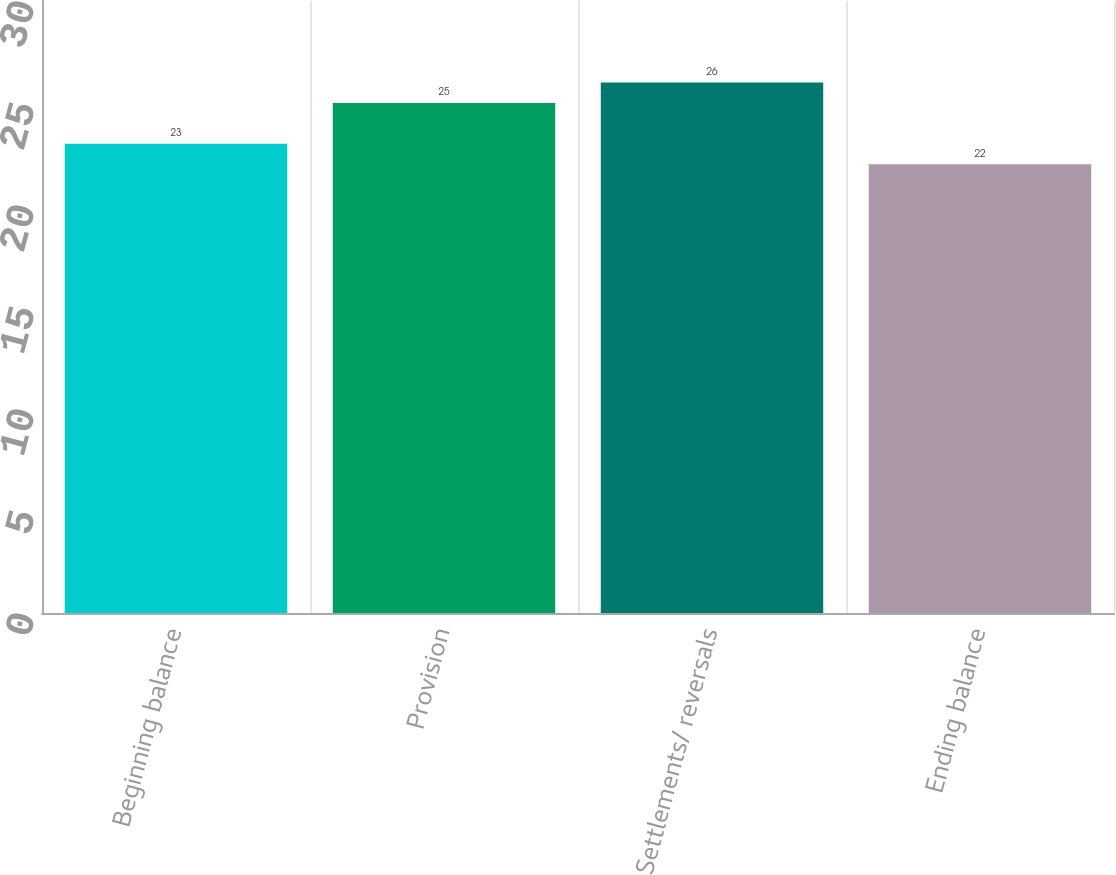Convert chart to OTSL. <chart><loc_0><loc_0><loc_500><loc_500><bar_chart><fcel>Beginning balance<fcel>Provision<fcel>Settlements/ reversals<fcel>Ending balance<nl><fcel>23<fcel>25<fcel>26<fcel>22<nl></chart> 